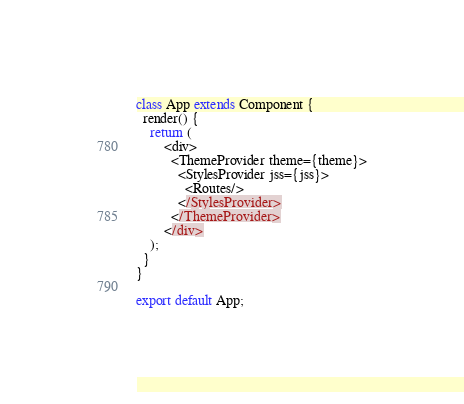Convert code to text. <code><loc_0><loc_0><loc_500><loc_500><_JavaScript_>class App extends Component {
  render() {
    return (
        <div>
          <ThemeProvider theme={theme}>
            <StylesProvider jss={jss}>
              <Routes/>
            </StylesProvider>
          </ThemeProvider>
        </div>
    );
  }
}

export default App;
</code> 